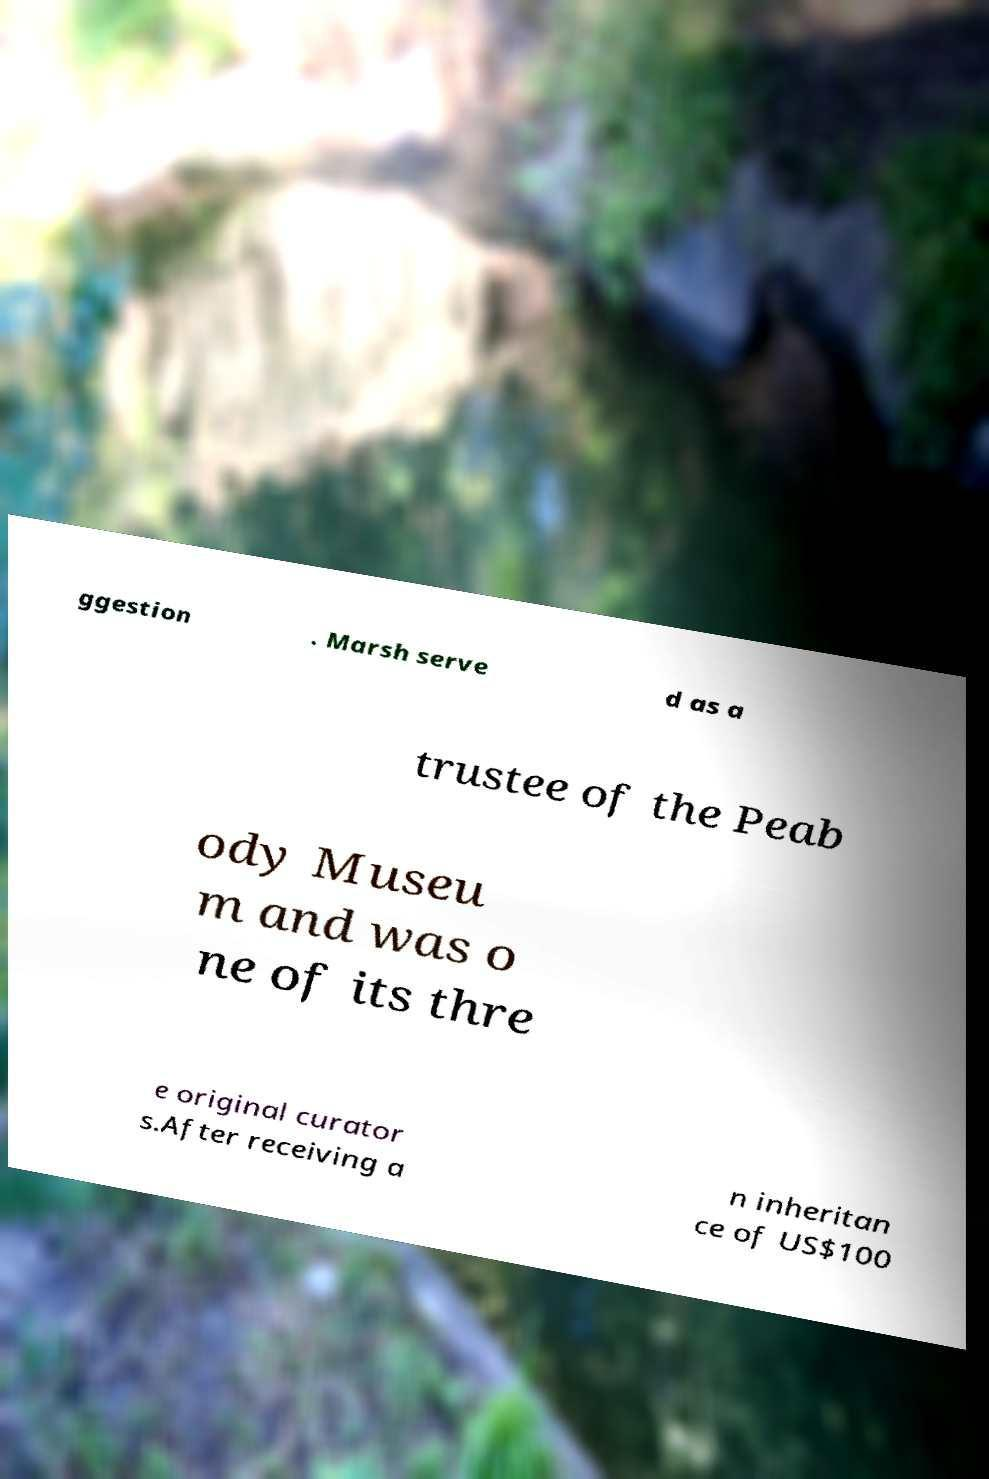There's text embedded in this image that I need extracted. Can you transcribe it verbatim? ggestion . Marsh serve d as a trustee of the Peab ody Museu m and was o ne of its thre e original curator s.After receiving a n inheritan ce of US$100 